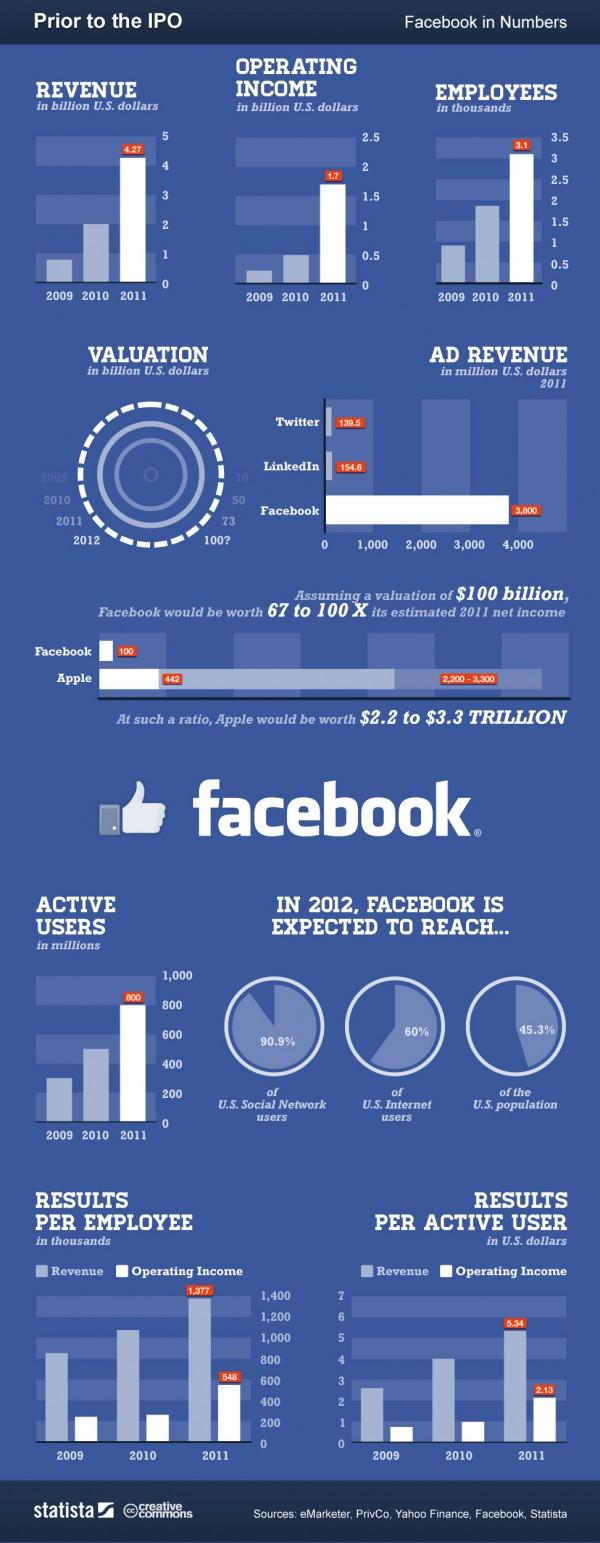Identify some key points in this picture. In 2011, the revenue was at its highest point. In 2011, the difference between revenue and operating income per active user was 3.21 US dollars. In 2011, Facebook was the social network that generated the most revenue from advertising. In the year 2011, the operating income was 1.7 billion U.S. dollars. 